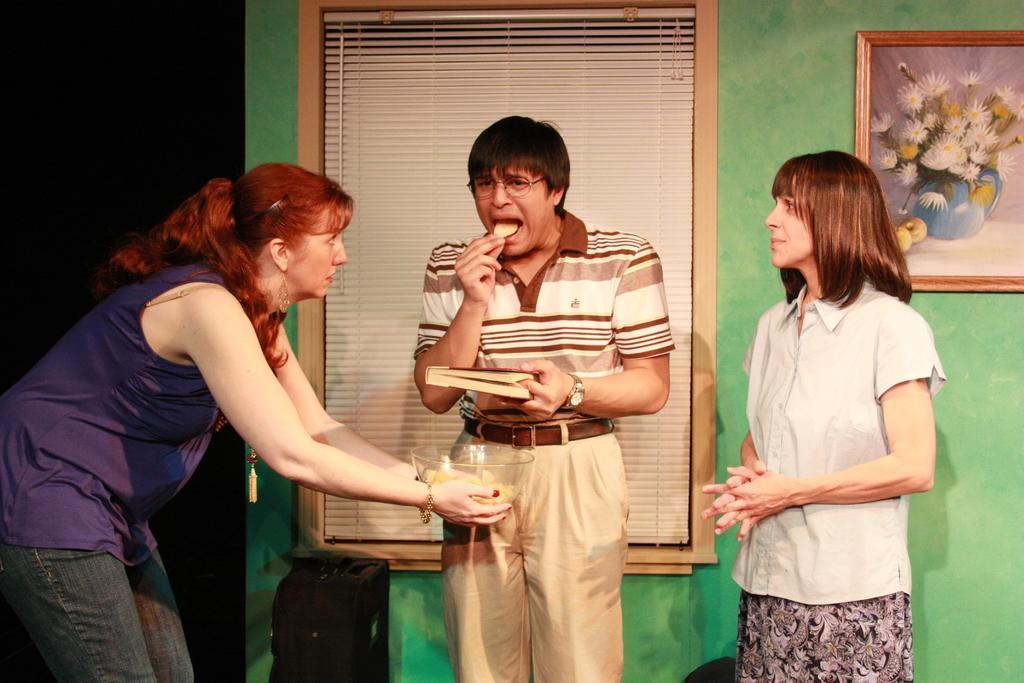How would you summarize this image in a sentence or two? In this image in the front there are persons standing. In the center there is a man standing and holding a book and eating. On the left side there is a woman standing and holding a bowl. In the background there is frame on the wall and there is a window and in front of the wall, there is an object which is black in colour. 